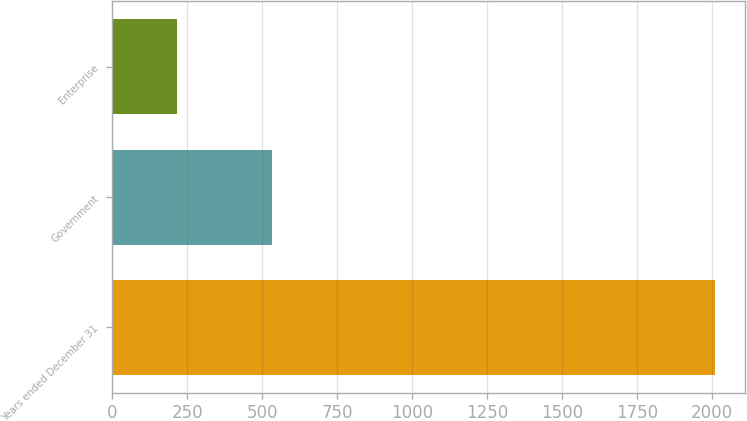<chart> <loc_0><loc_0><loc_500><loc_500><bar_chart><fcel>Years ended December 31<fcel>Government<fcel>Enterprise<nl><fcel>2010<fcel>534<fcel>217<nl></chart> 